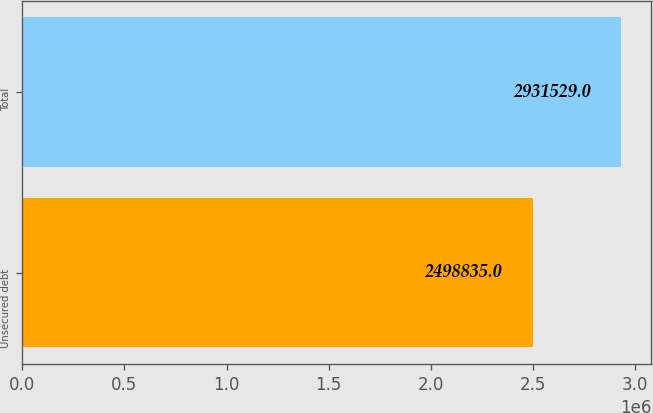Convert chart. <chart><loc_0><loc_0><loc_500><loc_500><bar_chart><fcel>Unsecured debt<fcel>Total<nl><fcel>2.49884e+06<fcel>2.93153e+06<nl></chart> 